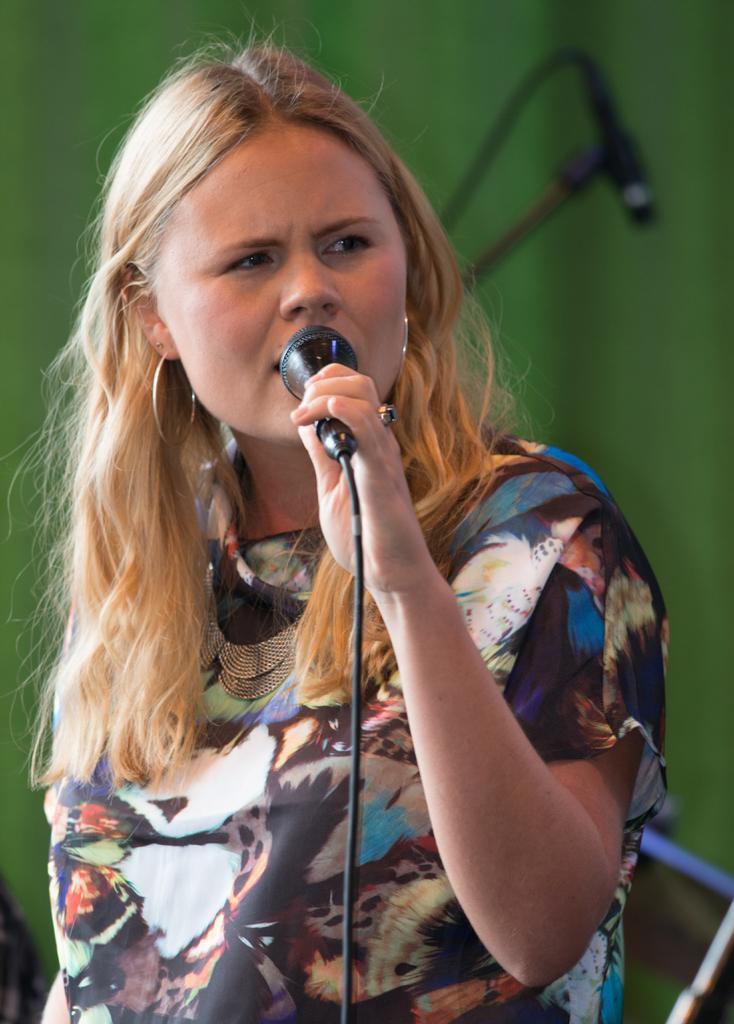Can you describe this image briefly? In this picture we can see woman holding mic in her hand and talking and in background we can see mic stand, green color wall. 